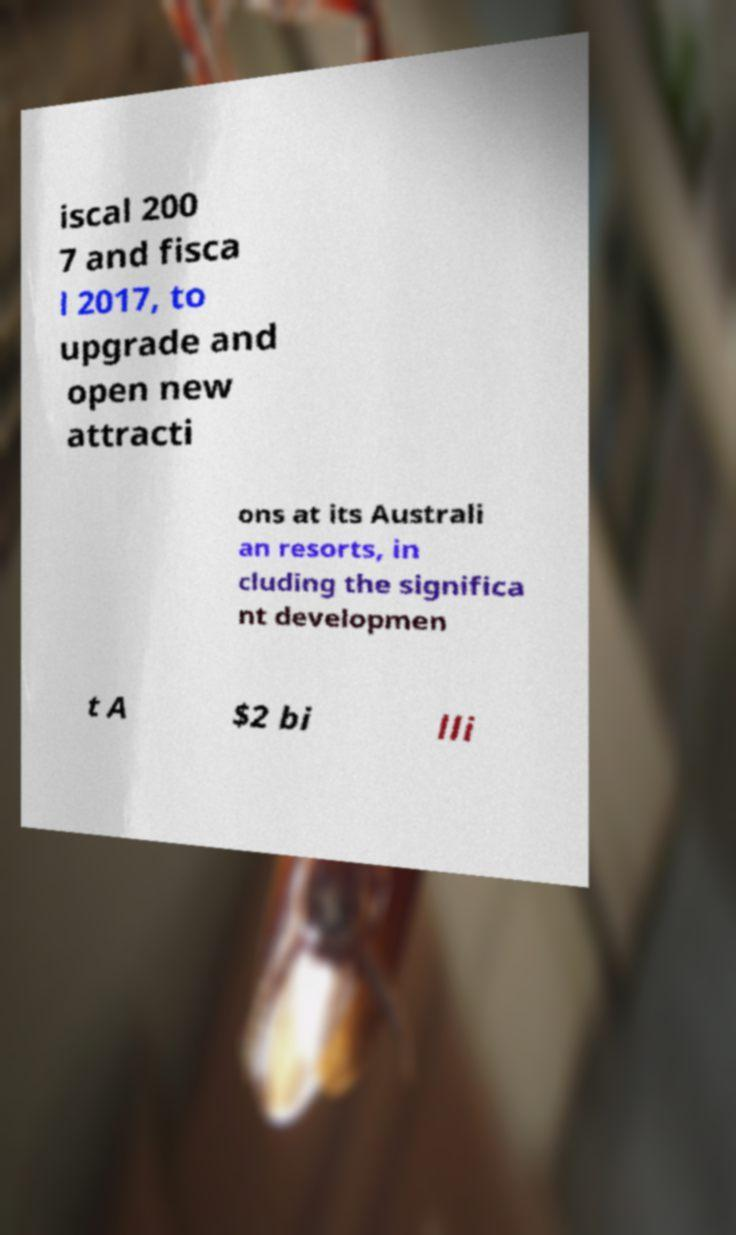Can you accurately transcribe the text from the provided image for me? iscal 200 7 and fisca l 2017, to upgrade and open new attracti ons at its Australi an resorts, in cluding the significa nt developmen t A $2 bi lli 